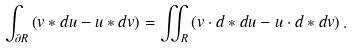Convert formula to latex. <formula><loc_0><loc_0><loc_500><loc_500>\int _ { \partial R } \left ( v \ast d u - u \ast d v \right ) = \iint _ { R } \left ( v \cdot d \ast d u - u \cdot d \ast d v \right ) .</formula> 